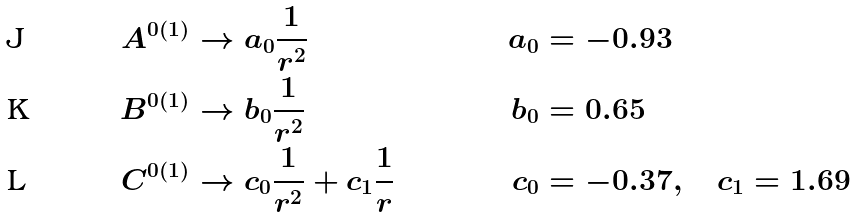Convert formula to latex. <formula><loc_0><loc_0><loc_500><loc_500>A ^ { 0 ( 1 ) } & \rightarrow a _ { 0 } \frac { 1 } { r ^ { 2 } } & a _ { 0 } & = - 0 . 9 3 \\ B ^ { 0 ( 1 ) } & \rightarrow b _ { 0 } \frac { 1 } { r ^ { 2 } } & b _ { 0 } & = 0 . 6 5 \\ C ^ { 0 ( 1 ) } & \rightarrow c _ { 0 } \frac { 1 } { r ^ { 2 } } + c _ { 1 } \frac { 1 } { r } & c _ { 0 } & = - 0 . 3 7 , \quad c _ { 1 } = 1 . 6 9</formula> 